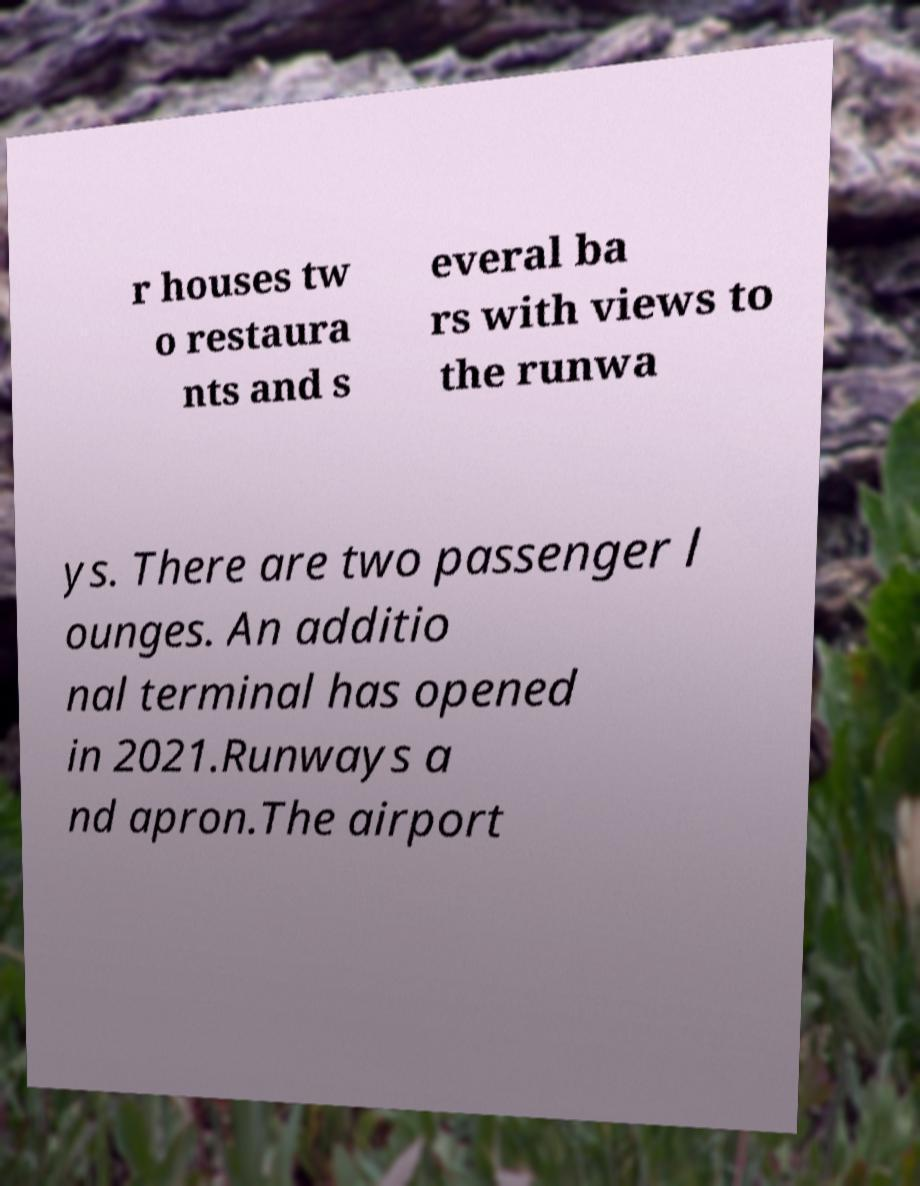What messages or text are displayed in this image? I need them in a readable, typed format. r houses tw o restaura nts and s everal ba rs with views to the runwa ys. There are two passenger l ounges. An additio nal terminal has opened in 2021.Runways a nd apron.The airport 